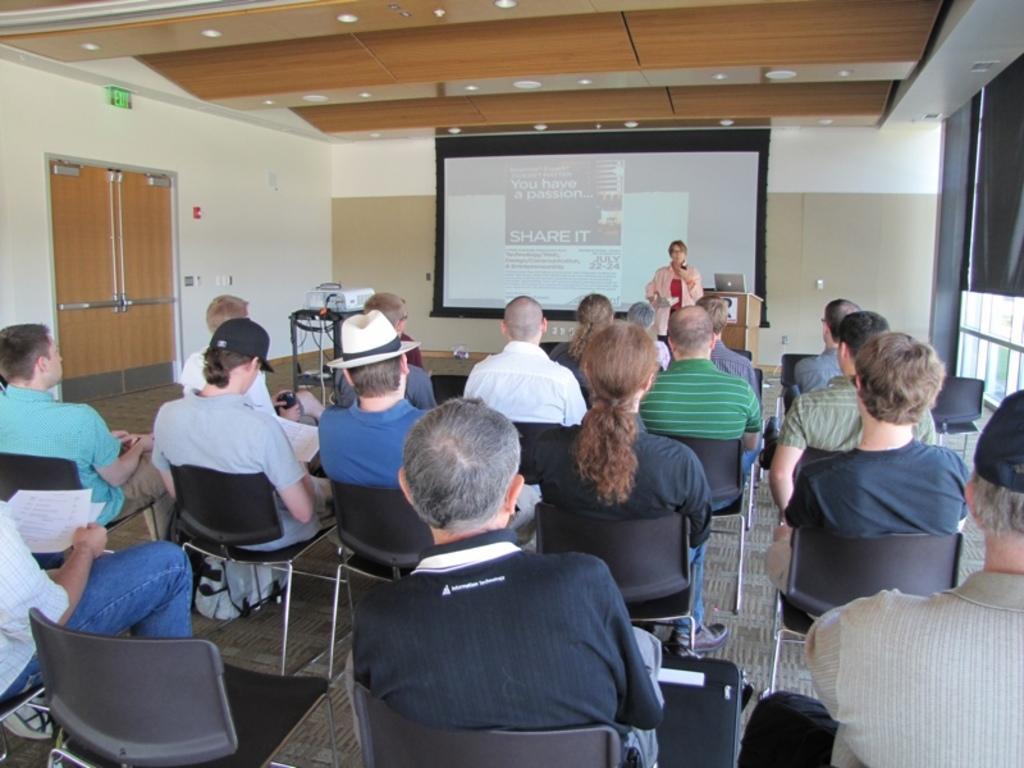Can you describe this image briefly? In this picture we can see group of people sitting on chair and listening to the woman standing beside the podium and on podium we have laptop and in background we can see screen, wall. 